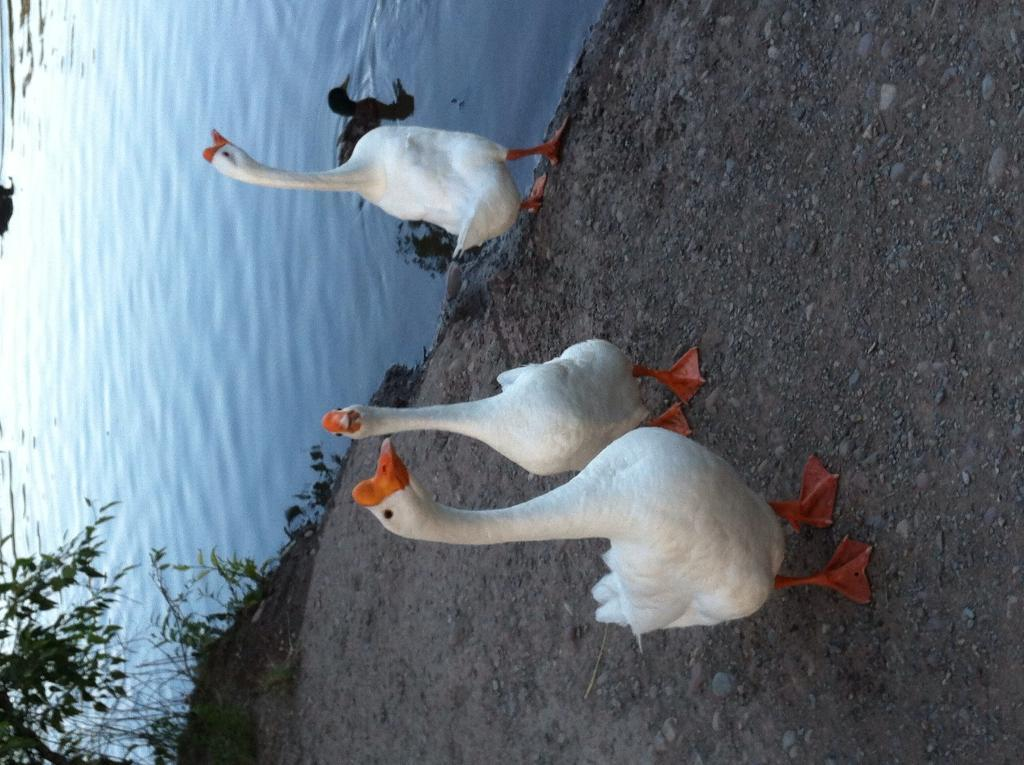What type of animals are on the ground in the image? There are white ducks on the ground in the image. What can be seen in the background of the image? There are trees visible in the image. What are the ducks doing in the water? A duck is swimming in the water. What hobbies do the ducks have while they are in jail? There is no indication that the ducks are in jail or have any hobbies in the image. 